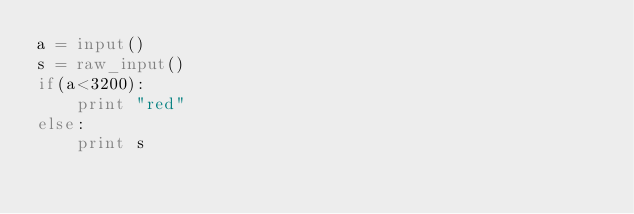<code> <loc_0><loc_0><loc_500><loc_500><_Python_>a = input()
s = raw_input()
if(a<3200):
    print "red"
else:
    print s</code> 